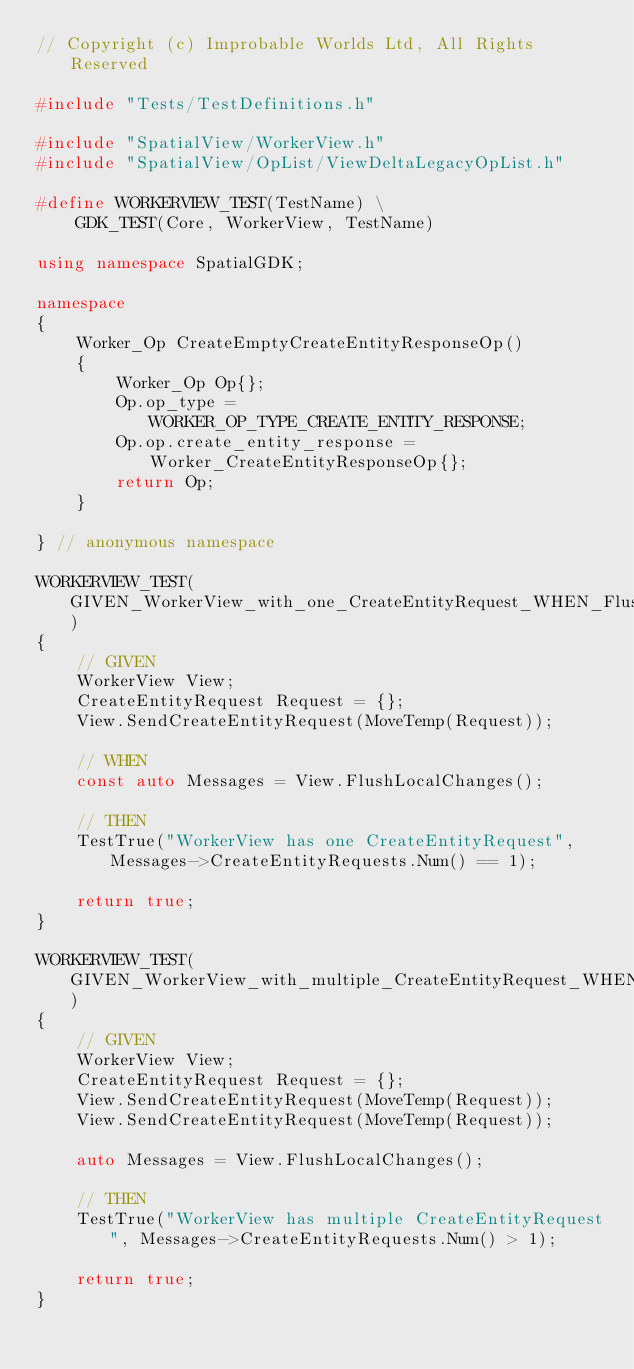Convert code to text. <code><loc_0><loc_0><loc_500><loc_500><_C++_>// Copyright (c) Improbable Worlds Ltd, All Rights Reserved

#include "Tests/TestDefinitions.h"

#include "SpatialView/WorkerView.h"
#include "SpatialView/OpList/ViewDeltaLegacyOpList.h"

#define WORKERVIEW_TEST(TestName) \
	GDK_TEST(Core, WorkerView, TestName)

using namespace SpatialGDK;

namespace
{
	Worker_Op CreateEmptyCreateEntityResponseOp()
	{
		Worker_Op Op{};
		Op.op_type = WORKER_OP_TYPE_CREATE_ENTITY_RESPONSE;
		Op.op.create_entity_response = Worker_CreateEntityResponseOp{};
		return Op;
	}

} // anonymous namespace

WORKERVIEW_TEST(GIVEN_WorkerView_with_one_CreateEntityRequest_WHEN_FlushLocalChanges_called_THEN_one_CreateEntityRequest_returned)
{
	// GIVEN
	WorkerView View;
	CreateEntityRequest Request = {};
	View.SendCreateEntityRequest(MoveTemp(Request));

	// WHEN
	const auto Messages = View.FlushLocalChanges();

	// THEN
	TestTrue("WorkerView has one CreateEntityRequest", Messages->CreateEntityRequests.Num() == 1);

	return true;
}

WORKERVIEW_TEST(GIVEN_WorkerView_with_multiple_CreateEntityRequest_WHEN_FlushLocalChanges_called_THEN_mutliple_CreateEntityRequests_returned)
{
	// GIVEN
	WorkerView View;
	CreateEntityRequest Request = {};
	View.SendCreateEntityRequest(MoveTemp(Request));
	View.SendCreateEntityRequest(MoveTemp(Request));

	auto Messages = View.FlushLocalChanges();

	// THEN
	TestTrue("WorkerView has multiple CreateEntityRequest", Messages->CreateEntityRequests.Num() > 1);

	return true;
}
</code> 